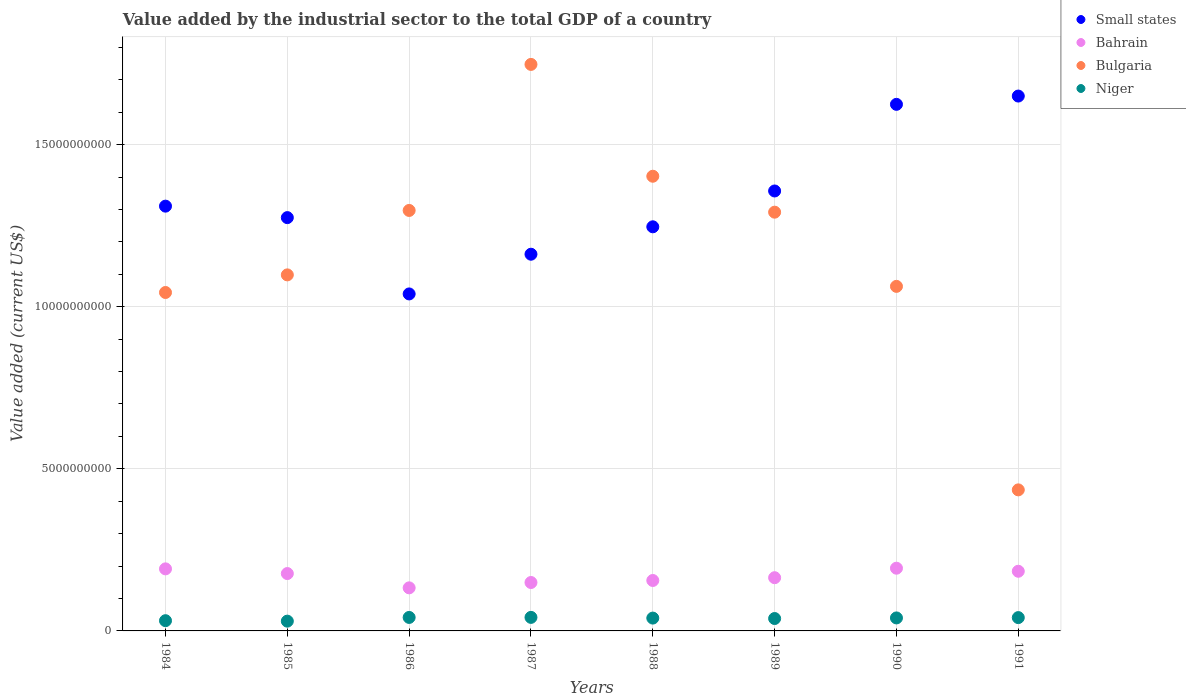How many different coloured dotlines are there?
Your answer should be very brief. 4. What is the value added by the industrial sector to the total GDP in Small states in 1987?
Your answer should be very brief. 1.16e+1. Across all years, what is the maximum value added by the industrial sector to the total GDP in Bahrain?
Give a very brief answer. 1.93e+09. Across all years, what is the minimum value added by the industrial sector to the total GDP in Small states?
Offer a terse response. 1.04e+1. What is the total value added by the industrial sector to the total GDP in Bulgaria in the graph?
Offer a terse response. 9.38e+1. What is the difference between the value added by the industrial sector to the total GDP in Niger in 1984 and that in 1989?
Your answer should be very brief. -6.68e+07. What is the difference between the value added by the industrial sector to the total GDP in Small states in 1988 and the value added by the industrial sector to the total GDP in Bahrain in 1989?
Keep it short and to the point. 1.08e+1. What is the average value added by the industrial sector to the total GDP in Small states per year?
Give a very brief answer. 1.33e+1. In the year 1985, what is the difference between the value added by the industrial sector to the total GDP in Bulgaria and value added by the industrial sector to the total GDP in Small states?
Offer a terse response. -1.77e+09. What is the ratio of the value added by the industrial sector to the total GDP in Niger in 1984 to that in 1988?
Your answer should be compact. 0.8. Is the difference between the value added by the industrial sector to the total GDP in Bulgaria in 1987 and 1988 greater than the difference between the value added by the industrial sector to the total GDP in Small states in 1987 and 1988?
Offer a terse response. Yes. What is the difference between the highest and the second highest value added by the industrial sector to the total GDP in Bahrain?
Keep it short and to the point. 2.04e+07. What is the difference between the highest and the lowest value added by the industrial sector to the total GDP in Niger?
Provide a short and direct response. 1.16e+08. How many dotlines are there?
Give a very brief answer. 4. How many legend labels are there?
Provide a short and direct response. 4. How are the legend labels stacked?
Your answer should be very brief. Vertical. What is the title of the graph?
Keep it short and to the point. Value added by the industrial sector to the total GDP of a country. What is the label or title of the Y-axis?
Keep it short and to the point. Value added (current US$). What is the Value added (current US$) of Small states in 1984?
Make the answer very short. 1.31e+1. What is the Value added (current US$) in Bahrain in 1984?
Ensure brevity in your answer.  1.91e+09. What is the Value added (current US$) in Bulgaria in 1984?
Offer a terse response. 1.04e+1. What is the Value added (current US$) of Niger in 1984?
Ensure brevity in your answer.  3.16e+08. What is the Value added (current US$) in Small states in 1985?
Your answer should be compact. 1.27e+1. What is the Value added (current US$) of Bahrain in 1985?
Ensure brevity in your answer.  1.77e+09. What is the Value added (current US$) in Bulgaria in 1985?
Your answer should be very brief. 1.10e+1. What is the Value added (current US$) in Niger in 1985?
Offer a very short reply. 3.01e+08. What is the Value added (current US$) in Small states in 1986?
Your answer should be very brief. 1.04e+1. What is the Value added (current US$) in Bahrain in 1986?
Give a very brief answer. 1.33e+09. What is the Value added (current US$) of Bulgaria in 1986?
Your response must be concise. 1.30e+1. What is the Value added (current US$) of Niger in 1986?
Offer a very short reply. 4.16e+08. What is the Value added (current US$) of Small states in 1987?
Keep it short and to the point. 1.16e+1. What is the Value added (current US$) in Bahrain in 1987?
Offer a very short reply. 1.49e+09. What is the Value added (current US$) in Bulgaria in 1987?
Your answer should be very brief. 1.75e+1. What is the Value added (current US$) in Niger in 1987?
Your answer should be very brief. 4.18e+08. What is the Value added (current US$) of Small states in 1988?
Your answer should be compact. 1.25e+1. What is the Value added (current US$) of Bahrain in 1988?
Give a very brief answer. 1.56e+09. What is the Value added (current US$) of Bulgaria in 1988?
Your answer should be very brief. 1.40e+1. What is the Value added (current US$) of Niger in 1988?
Offer a very short reply. 3.96e+08. What is the Value added (current US$) of Small states in 1989?
Make the answer very short. 1.36e+1. What is the Value added (current US$) in Bahrain in 1989?
Give a very brief answer. 1.64e+09. What is the Value added (current US$) in Bulgaria in 1989?
Your answer should be very brief. 1.29e+1. What is the Value added (current US$) of Niger in 1989?
Ensure brevity in your answer.  3.82e+08. What is the Value added (current US$) in Small states in 1990?
Keep it short and to the point. 1.62e+1. What is the Value added (current US$) in Bahrain in 1990?
Give a very brief answer. 1.93e+09. What is the Value added (current US$) in Bulgaria in 1990?
Your answer should be compact. 1.06e+1. What is the Value added (current US$) of Niger in 1990?
Ensure brevity in your answer.  4.01e+08. What is the Value added (current US$) of Small states in 1991?
Your answer should be very brief. 1.65e+1. What is the Value added (current US$) of Bahrain in 1991?
Give a very brief answer. 1.84e+09. What is the Value added (current US$) of Bulgaria in 1991?
Your answer should be very brief. 4.35e+09. What is the Value added (current US$) of Niger in 1991?
Your answer should be very brief. 4.11e+08. Across all years, what is the maximum Value added (current US$) of Small states?
Provide a succinct answer. 1.65e+1. Across all years, what is the maximum Value added (current US$) of Bahrain?
Provide a succinct answer. 1.93e+09. Across all years, what is the maximum Value added (current US$) of Bulgaria?
Provide a succinct answer. 1.75e+1. Across all years, what is the maximum Value added (current US$) of Niger?
Offer a very short reply. 4.18e+08. Across all years, what is the minimum Value added (current US$) in Small states?
Provide a succinct answer. 1.04e+1. Across all years, what is the minimum Value added (current US$) in Bahrain?
Offer a terse response. 1.33e+09. Across all years, what is the minimum Value added (current US$) in Bulgaria?
Your answer should be compact. 4.35e+09. Across all years, what is the minimum Value added (current US$) in Niger?
Provide a succinct answer. 3.01e+08. What is the total Value added (current US$) of Small states in the graph?
Keep it short and to the point. 1.07e+11. What is the total Value added (current US$) of Bahrain in the graph?
Provide a short and direct response. 1.35e+1. What is the total Value added (current US$) of Bulgaria in the graph?
Your response must be concise. 9.38e+1. What is the total Value added (current US$) of Niger in the graph?
Give a very brief answer. 3.04e+09. What is the difference between the Value added (current US$) in Small states in 1984 and that in 1985?
Keep it short and to the point. 3.54e+08. What is the difference between the Value added (current US$) of Bahrain in 1984 and that in 1985?
Your answer should be compact. 1.45e+08. What is the difference between the Value added (current US$) in Bulgaria in 1984 and that in 1985?
Provide a short and direct response. -5.43e+08. What is the difference between the Value added (current US$) in Niger in 1984 and that in 1985?
Keep it short and to the point. 1.42e+07. What is the difference between the Value added (current US$) in Small states in 1984 and that in 1986?
Your answer should be compact. 2.71e+09. What is the difference between the Value added (current US$) in Bahrain in 1984 and that in 1986?
Offer a very short reply. 5.86e+08. What is the difference between the Value added (current US$) in Bulgaria in 1984 and that in 1986?
Provide a succinct answer. -2.53e+09. What is the difference between the Value added (current US$) in Niger in 1984 and that in 1986?
Offer a very short reply. -1.00e+08. What is the difference between the Value added (current US$) in Small states in 1984 and that in 1987?
Provide a succinct answer. 1.48e+09. What is the difference between the Value added (current US$) in Bahrain in 1984 and that in 1987?
Your answer should be compact. 4.21e+08. What is the difference between the Value added (current US$) of Bulgaria in 1984 and that in 1987?
Provide a short and direct response. -7.04e+09. What is the difference between the Value added (current US$) in Niger in 1984 and that in 1987?
Your response must be concise. -1.02e+08. What is the difference between the Value added (current US$) of Small states in 1984 and that in 1988?
Offer a very short reply. 6.37e+08. What is the difference between the Value added (current US$) in Bahrain in 1984 and that in 1988?
Provide a short and direct response. 3.58e+08. What is the difference between the Value added (current US$) of Bulgaria in 1984 and that in 1988?
Provide a succinct answer. -3.59e+09. What is the difference between the Value added (current US$) in Niger in 1984 and that in 1988?
Provide a succinct answer. -8.02e+07. What is the difference between the Value added (current US$) in Small states in 1984 and that in 1989?
Give a very brief answer. -4.68e+08. What is the difference between the Value added (current US$) in Bahrain in 1984 and that in 1989?
Ensure brevity in your answer.  2.73e+08. What is the difference between the Value added (current US$) in Bulgaria in 1984 and that in 1989?
Your response must be concise. -2.48e+09. What is the difference between the Value added (current US$) in Niger in 1984 and that in 1989?
Your response must be concise. -6.68e+07. What is the difference between the Value added (current US$) of Small states in 1984 and that in 1990?
Your answer should be compact. -3.14e+09. What is the difference between the Value added (current US$) in Bahrain in 1984 and that in 1990?
Your response must be concise. -2.04e+07. What is the difference between the Value added (current US$) of Bulgaria in 1984 and that in 1990?
Provide a succinct answer. -1.89e+08. What is the difference between the Value added (current US$) of Niger in 1984 and that in 1990?
Provide a short and direct response. -8.51e+07. What is the difference between the Value added (current US$) in Small states in 1984 and that in 1991?
Provide a short and direct response. -3.40e+09. What is the difference between the Value added (current US$) of Bahrain in 1984 and that in 1991?
Your answer should be compact. 7.39e+07. What is the difference between the Value added (current US$) in Bulgaria in 1984 and that in 1991?
Provide a short and direct response. 6.09e+09. What is the difference between the Value added (current US$) in Niger in 1984 and that in 1991?
Your answer should be very brief. -9.52e+07. What is the difference between the Value added (current US$) in Small states in 1985 and that in 1986?
Ensure brevity in your answer.  2.35e+09. What is the difference between the Value added (current US$) in Bahrain in 1985 and that in 1986?
Give a very brief answer. 4.41e+08. What is the difference between the Value added (current US$) of Bulgaria in 1985 and that in 1986?
Keep it short and to the point. -1.99e+09. What is the difference between the Value added (current US$) of Niger in 1985 and that in 1986?
Provide a succinct answer. -1.14e+08. What is the difference between the Value added (current US$) of Small states in 1985 and that in 1987?
Offer a terse response. 1.13e+09. What is the difference between the Value added (current US$) in Bahrain in 1985 and that in 1987?
Offer a very short reply. 2.76e+08. What is the difference between the Value added (current US$) in Bulgaria in 1985 and that in 1987?
Offer a terse response. -6.49e+09. What is the difference between the Value added (current US$) of Niger in 1985 and that in 1987?
Give a very brief answer. -1.16e+08. What is the difference between the Value added (current US$) of Small states in 1985 and that in 1988?
Offer a terse response. 2.83e+08. What is the difference between the Value added (current US$) of Bahrain in 1985 and that in 1988?
Provide a short and direct response. 2.14e+08. What is the difference between the Value added (current US$) in Bulgaria in 1985 and that in 1988?
Provide a succinct answer. -3.04e+09. What is the difference between the Value added (current US$) in Niger in 1985 and that in 1988?
Provide a succinct answer. -9.45e+07. What is the difference between the Value added (current US$) in Small states in 1985 and that in 1989?
Give a very brief answer. -8.22e+08. What is the difference between the Value added (current US$) in Bahrain in 1985 and that in 1989?
Provide a short and direct response. 1.28e+08. What is the difference between the Value added (current US$) of Bulgaria in 1985 and that in 1989?
Provide a short and direct response. -1.93e+09. What is the difference between the Value added (current US$) of Niger in 1985 and that in 1989?
Ensure brevity in your answer.  -8.11e+07. What is the difference between the Value added (current US$) in Small states in 1985 and that in 1990?
Your answer should be very brief. -3.49e+09. What is the difference between the Value added (current US$) in Bahrain in 1985 and that in 1990?
Offer a terse response. -1.65e+08. What is the difference between the Value added (current US$) in Bulgaria in 1985 and that in 1990?
Your answer should be compact. 3.54e+08. What is the difference between the Value added (current US$) of Niger in 1985 and that in 1990?
Offer a terse response. -9.93e+07. What is the difference between the Value added (current US$) in Small states in 1985 and that in 1991?
Offer a very short reply. -3.75e+09. What is the difference between the Value added (current US$) in Bahrain in 1985 and that in 1991?
Make the answer very short. -7.08e+07. What is the difference between the Value added (current US$) of Bulgaria in 1985 and that in 1991?
Your answer should be very brief. 6.63e+09. What is the difference between the Value added (current US$) in Niger in 1985 and that in 1991?
Make the answer very short. -1.09e+08. What is the difference between the Value added (current US$) in Small states in 1986 and that in 1987?
Ensure brevity in your answer.  -1.22e+09. What is the difference between the Value added (current US$) of Bahrain in 1986 and that in 1987?
Your answer should be compact. -1.65e+08. What is the difference between the Value added (current US$) in Bulgaria in 1986 and that in 1987?
Offer a very short reply. -4.50e+09. What is the difference between the Value added (current US$) in Niger in 1986 and that in 1987?
Ensure brevity in your answer.  -1.77e+06. What is the difference between the Value added (current US$) of Small states in 1986 and that in 1988?
Offer a very short reply. -2.07e+09. What is the difference between the Value added (current US$) of Bahrain in 1986 and that in 1988?
Offer a very short reply. -2.27e+08. What is the difference between the Value added (current US$) of Bulgaria in 1986 and that in 1988?
Ensure brevity in your answer.  -1.06e+09. What is the difference between the Value added (current US$) in Niger in 1986 and that in 1988?
Provide a succinct answer. 2.00e+07. What is the difference between the Value added (current US$) in Small states in 1986 and that in 1989?
Provide a short and direct response. -3.18e+09. What is the difference between the Value added (current US$) of Bahrain in 1986 and that in 1989?
Your response must be concise. -3.13e+08. What is the difference between the Value added (current US$) of Bulgaria in 1986 and that in 1989?
Your answer should be very brief. 5.32e+07. What is the difference between the Value added (current US$) of Niger in 1986 and that in 1989?
Give a very brief answer. 3.34e+07. What is the difference between the Value added (current US$) of Small states in 1986 and that in 1990?
Provide a short and direct response. -5.85e+09. What is the difference between the Value added (current US$) in Bahrain in 1986 and that in 1990?
Your response must be concise. -6.06e+08. What is the difference between the Value added (current US$) of Bulgaria in 1986 and that in 1990?
Make the answer very short. 2.34e+09. What is the difference between the Value added (current US$) of Niger in 1986 and that in 1990?
Offer a very short reply. 1.51e+07. What is the difference between the Value added (current US$) in Small states in 1986 and that in 1991?
Offer a terse response. -6.10e+09. What is the difference between the Value added (current US$) of Bahrain in 1986 and that in 1991?
Offer a very short reply. -5.12e+08. What is the difference between the Value added (current US$) in Bulgaria in 1986 and that in 1991?
Offer a terse response. 8.62e+09. What is the difference between the Value added (current US$) of Niger in 1986 and that in 1991?
Offer a terse response. 4.98e+06. What is the difference between the Value added (current US$) in Small states in 1987 and that in 1988?
Offer a very short reply. -8.46e+08. What is the difference between the Value added (current US$) of Bahrain in 1987 and that in 1988?
Your answer should be compact. -6.23e+07. What is the difference between the Value added (current US$) in Bulgaria in 1987 and that in 1988?
Give a very brief answer. 3.45e+09. What is the difference between the Value added (current US$) of Niger in 1987 and that in 1988?
Your answer should be very brief. 2.17e+07. What is the difference between the Value added (current US$) in Small states in 1987 and that in 1989?
Provide a succinct answer. -1.95e+09. What is the difference between the Value added (current US$) in Bahrain in 1987 and that in 1989?
Provide a succinct answer. -1.48e+08. What is the difference between the Value added (current US$) in Bulgaria in 1987 and that in 1989?
Provide a short and direct response. 4.56e+09. What is the difference between the Value added (current US$) of Niger in 1987 and that in 1989?
Keep it short and to the point. 3.52e+07. What is the difference between the Value added (current US$) in Small states in 1987 and that in 1990?
Your answer should be compact. -4.62e+09. What is the difference between the Value added (current US$) of Bahrain in 1987 and that in 1990?
Your answer should be compact. -4.41e+08. What is the difference between the Value added (current US$) of Bulgaria in 1987 and that in 1990?
Make the answer very short. 6.85e+09. What is the difference between the Value added (current US$) of Niger in 1987 and that in 1990?
Your answer should be compact. 1.69e+07. What is the difference between the Value added (current US$) in Small states in 1987 and that in 1991?
Your response must be concise. -4.88e+09. What is the difference between the Value added (current US$) of Bahrain in 1987 and that in 1991?
Offer a very short reply. -3.47e+08. What is the difference between the Value added (current US$) in Bulgaria in 1987 and that in 1991?
Your answer should be very brief. 1.31e+1. What is the difference between the Value added (current US$) of Niger in 1987 and that in 1991?
Provide a short and direct response. 6.75e+06. What is the difference between the Value added (current US$) in Small states in 1988 and that in 1989?
Your response must be concise. -1.11e+09. What is the difference between the Value added (current US$) in Bahrain in 1988 and that in 1989?
Ensure brevity in your answer.  -8.59e+07. What is the difference between the Value added (current US$) of Bulgaria in 1988 and that in 1989?
Your answer should be compact. 1.11e+09. What is the difference between the Value added (current US$) of Niger in 1988 and that in 1989?
Your answer should be compact. 1.34e+07. What is the difference between the Value added (current US$) of Small states in 1988 and that in 1990?
Offer a terse response. -3.78e+09. What is the difference between the Value added (current US$) of Bahrain in 1988 and that in 1990?
Offer a very short reply. -3.79e+08. What is the difference between the Value added (current US$) in Bulgaria in 1988 and that in 1990?
Your answer should be very brief. 3.40e+09. What is the difference between the Value added (current US$) in Niger in 1988 and that in 1990?
Provide a short and direct response. -4.87e+06. What is the difference between the Value added (current US$) of Small states in 1988 and that in 1991?
Provide a succinct answer. -4.03e+09. What is the difference between the Value added (current US$) in Bahrain in 1988 and that in 1991?
Your answer should be compact. -2.85e+08. What is the difference between the Value added (current US$) of Bulgaria in 1988 and that in 1991?
Your answer should be compact. 9.67e+09. What is the difference between the Value added (current US$) in Niger in 1988 and that in 1991?
Your answer should be very brief. -1.50e+07. What is the difference between the Value added (current US$) of Small states in 1989 and that in 1990?
Keep it short and to the point. -2.67e+09. What is the difference between the Value added (current US$) in Bahrain in 1989 and that in 1990?
Your response must be concise. -2.93e+08. What is the difference between the Value added (current US$) in Bulgaria in 1989 and that in 1990?
Your answer should be very brief. 2.29e+09. What is the difference between the Value added (current US$) in Niger in 1989 and that in 1990?
Your answer should be compact. -1.83e+07. What is the difference between the Value added (current US$) in Small states in 1989 and that in 1991?
Your response must be concise. -2.93e+09. What is the difference between the Value added (current US$) in Bahrain in 1989 and that in 1991?
Offer a terse response. -1.99e+08. What is the difference between the Value added (current US$) in Bulgaria in 1989 and that in 1991?
Give a very brief answer. 8.57e+09. What is the difference between the Value added (current US$) in Niger in 1989 and that in 1991?
Your answer should be very brief. -2.84e+07. What is the difference between the Value added (current US$) in Small states in 1990 and that in 1991?
Provide a succinct answer. -2.56e+08. What is the difference between the Value added (current US$) in Bahrain in 1990 and that in 1991?
Provide a short and direct response. 9.42e+07. What is the difference between the Value added (current US$) of Bulgaria in 1990 and that in 1991?
Provide a short and direct response. 6.28e+09. What is the difference between the Value added (current US$) in Niger in 1990 and that in 1991?
Provide a short and direct response. -1.01e+07. What is the difference between the Value added (current US$) of Small states in 1984 and the Value added (current US$) of Bahrain in 1985?
Ensure brevity in your answer.  1.13e+1. What is the difference between the Value added (current US$) of Small states in 1984 and the Value added (current US$) of Bulgaria in 1985?
Your answer should be compact. 2.12e+09. What is the difference between the Value added (current US$) in Small states in 1984 and the Value added (current US$) in Niger in 1985?
Provide a succinct answer. 1.28e+1. What is the difference between the Value added (current US$) of Bahrain in 1984 and the Value added (current US$) of Bulgaria in 1985?
Your answer should be compact. -9.07e+09. What is the difference between the Value added (current US$) in Bahrain in 1984 and the Value added (current US$) in Niger in 1985?
Offer a very short reply. 1.61e+09. What is the difference between the Value added (current US$) in Bulgaria in 1984 and the Value added (current US$) in Niger in 1985?
Offer a very short reply. 1.01e+1. What is the difference between the Value added (current US$) of Small states in 1984 and the Value added (current US$) of Bahrain in 1986?
Offer a very short reply. 1.18e+1. What is the difference between the Value added (current US$) in Small states in 1984 and the Value added (current US$) in Bulgaria in 1986?
Your answer should be very brief. 1.33e+08. What is the difference between the Value added (current US$) in Small states in 1984 and the Value added (current US$) in Niger in 1986?
Provide a succinct answer. 1.27e+1. What is the difference between the Value added (current US$) in Bahrain in 1984 and the Value added (current US$) in Bulgaria in 1986?
Provide a short and direct response. -1.11e+1. What is the difference between the Value added (current US$) in Bahrain in 1984 and the Value added (current US$) in Niger in 1986?
Your answer should be very brief. 1.50e+09. What is the difference between the Value added (current US$) in Bulgaria in 1984 and the Value added (current US$) in Niger in 1986?
Ensure brevity in your answer.  1.00e+1. What is the difference between the Value added (current US$) in Small states in 1984 and the Value added (current US$) in Bahrain in 1987?
Your answer should be very brief. 1.16e+1. What is the difference between the Value added (current US$) in Small states in 1984 and the Value added (current US$) in Bulgaria in 1987?
Give a very brief answer. -4.37e+09. What is the difference between the Value added (current US$) of Small states in 1984 and the Value added (current US$) of Niger in 1987?
Your answer should be very brief. 1.27e+1. What is the difference between the Value added (current US$) of Bahrain in 1984 and the Value added (current US$) of Bulgaria in 1987?
Offer a very short reply. -1.56e+1. What is the difference between the Value added (current US$) of Bahrain in 1984 and the Value added (current US$) of Niger in 1987?
Give a very brief answer. 1.50e+09. What is the difference between the Value added (current US$) of Bulgaria in 1984 and the Value added (current US$) of Niger in 1987?
Offer a terse response. 1.00e+1. What is the difference between the Value added (current US$) of Small states in 1984 and the Value added (current US$) of Bahrain in 1988?
Ensure brevity in your answer.  1.15e+1. What is the difference between the Value added (current US$) in Small states in 1984 and the Value added (current US$) in Bulgaria in 1988?
Your response must be concise. -9.23e+08. What is the difference between the Value added (current US$) of Small states in 1984 and the Value added (current US$) of Niger in 1988?
Ensure brevity in your answer.  1.27e+1. What is the difference between the Value added (current US$) in Bahrain in 1984 and the Value added (current US$) in Bulgaria in 1988?
Make the answer very short. -1.21e+1. What is the difference between the Value added (current US$) in Bahrain in 1984 and the Value added (current US$) in Niger in 1988?
Offer a terse response. 1.52e+09. What is the difference between the Value added (current US$) of Bulgaria in 1984 and the Value added (current US$) of Niger in 1988?
Ensure brevity in your answer.  1.00e+1. What is the difference between the Value added (current US$) in Small states in 1984 and the Value added (current US$) in Bahrain in 1989?
Your answer should be compact. 1.15e+1. What is the difference between the Value added (current US$) of Small states in 1984 and the Value added (current US$) of Bulgaria in 1989?
Make the answer very short. 1.86e+08. What is the difference between the Value added (current US$) of Small states in 1984 and the Value added (current US$) of Niger in 1989?
Give a very brief answer. 1.27e+1. What is the difference between the Value added (current US$) in Bahrain in 1984 and the Value added (current US$) in Bulgaria in 1989?
Your answer should be compact. -1.10e+1. What is the difference between the Value added (current US$) in Bahrain in 1984 and the Value added (current US$) in Niger in 1989?
Give a very brief answer. 1.53e+09. What is the difference between the Value added (current US$) in Bulgaria in 1984 and the Value added (current US$) in Niger in 1989?
Your answer should be compact. 1.01e+1. What is the difference between the Value added (current US$) in Small states in 1984 and the Value added (current US$) in Bahrain in 1990?
Give a very brief answer. 1.12e+1. What is the difference between the Value added (current US$) in Small states in 1984 and the Value added (current US$) in Bulgaria in 1990?
Keep it short and to the point. 2.47e+09. What is the difference between the Value added (current US$) of Small states in 1984 and the Value added (current US$) of Niger in 1990?
Ensure brevity in your answer.  1.27e+1. What is the difference between the Value added (current US$) of Bahrain in 1984 and the Value added (current US$) of Bulgaria in 1990?
Provide a short and direct response. -8.71e+09. What is the difference between the Value added (current US$) of Bahrain in 1984 and the Value added (current US$) of Niger in 1990?
Offer a terse response. 1.51e+09. What is the difference between the Value added (current US$) of Bulgaria in 1984 and the Value added (current US$) of Niger in 1990?
Provide a short and direct response. 1.00e+1. What is the difference between the Value added (current US$) of Small states in 1984 and the Value added (current US$) of Bahrain in 1991?
Provide a short and direct response. 1.13e+1. What is the difference between the Value added (current US$) of Small states in 1984 and the Value added (current US$) of Bulgaria in 1991?
Your answer should be compact. 8.75e+09. What is the difference between the Value added (current US$) in Small states in 1984 and the Value added (current US$) in Niger in 1991?
Provide a short and direct response. 1.27e+1. What is the difference between the Value added (current US$) of Bahrain in 1984 and the Value added (current US$) of Bulgaria in 1991?
Give a very brief answer. -2.44e+09. What is the difference between the Value added (current US$) in Bahrain in 1984 and the Value added (current US$) in Niger in 1991?
Your answer should be compact. 1.50e+09. What is the difference between the Value added (current US$) of Bulgaria in 1984 and the Value added (current US$) of Niger in 1991?
Provide a succinct answer. 1.00e+1. What is the difference between the Value added (current US$) of Small states in 1985 and the Value added (current US$) of Bahrain in 1986?
Ensure brevity in your answer.  1.14e+1. What is the difference between the Value added (current US$) in Small states in 1985 and the Value added (current US$) in Bulgaria in 1986?
Keep it short and to the point. -2.21e+08. What is the difference between the Value added (current US$) in Small states in 1985 and the Value added (current US$) in Niger in 1986?
Your answer should be very brief. 1.23e+1. What is the difference between the Value added (current US$) in Bahrain in 1985 and the Value added (current US$) in Bulgaria in 1986?
Ensure brevity in your answer.  -1.12e+1. What is the difference between the Value added (current US$) of Bahrain in 1985 and the Value added (current US$) of Niger in 1986?
Your answer should be compact. 1.35e+09. What is the difference between the Value added (current US$) in Bulgaria in 1985 and the Value added (current US$) in Niger in 1986?
Make the answer very short. 1.06e+1. What is the difference between the Value added (current US$) in Small states in 1985 and the Value added (current US$) in Bahrain in 1987?
Provide a short and direct response. 1.13e+1. What is the difference between the Value added (current US$) in Small states in 1985 and the Value added (current US$) in Bulgaria in 1987?
Your answer should be very brief. -4.73e+09. What is the difference between the Value added (current US$) of Small states in 1985 and the Value added (current US$) of Niger in 1987?
Your answer should be compact. 1.23e+1. What is the difference between the Value added (current US$) in Bahrain in 1985 and the Value added (current US$) in Bulgaria in 1987?
Keep it short and to the point. -1.57e+1. What is the difference between the Value added (current US$) in Bahrain in 1985 and the Value added (current US$) in Niger in 1987?
Your answer should be compact. 1.35e+09. What is the difference between the Value added (current US$) of Bulgaria in 1985 and the Value added (current US$) of Niger in 1987?
Offer a terse response. 1.06e+1. What is the difference between the Value added (current US$) in Small states in 1985 and the Value added (current US$) in Bahrain in 1988?
Your answer should be compact. 1.12e+1. What is the difference between the Value added (current US$) of Small states in 1985 and the Value added (current US$) of Bulgaria in 1988?
Keep it short and to the point. -1.28e+09. What is the difference between the Value added (current US$) in Small states in 1985 and the Value added (current US$) in Niger in 1988?
Your answer should be very brief. 1.24e+1. What is the difference between the Value added (current US$) of Bahrain in 1985 and the Value added (current US$) of Bulgaria in 1988?
Your answer should be very brief. -1.23e+1. What is the difference between the Value added (current US$) in Bahrain in 1985 and the Value added (current US$) in Niger in 1988?
Offer a very short reply. 1.37e+09. What is the difference between the Value added (current US$) in Bulgaria in 1985 and the Value added (current US$) in Niger in 1988?
Your response must be concise. 1.06e+1. What is the difference between the Value added (current US$) of Small states in 1985 and the Value added (current US$) of Bahrain in 1989?
Provide a short and direct response. 1.11e+1. What is the difference between the Value added (current US$) of Small states in 1985 and the Value added (current US$) of Bulgaria in 1989?
Your response must be concise. -1.68e+08. What is the difference between the Value added (current US$) in Small states in 1985 and the Value added (current US$) in Niger in 1989?
Offer a very short reply. 1.24e+1. What is the difference between the Value added (current US$) of Bahrain in 1985 and the Value added (current US$) of Bulgaria in 1989?
Provide a succinct answer. -1.11e+1. What is the difference between the Value added (current US$) of Bahrain in 1985 and the Value added (current US$) of Niger in 1989?
Ensure brevity in your answer.  1.39e+09. What is the difference between the Value added (current US$) in Bulgaria in 1985 and the Value added (current US$) in Niger in 1989?
Keep it short and to the point. 1.06e+1. What is the difference between the Value added (current US$) in Small states in 1985 and the Value added (current US$) in Bahrain in 1990?
Keep it short and to the point. 1.08e+1. What is the difference between the Value added (current US$) in Small states in 1985 and the Value added (current US$) in Bulgaria in 1990?
Your answer should be very brief. 2.12e+09. What is the difference between the Value added (current US$) in Small states in 1985 and the Value added (current US$) in Niger in 1990?
Provide a succinct answer. 1.23e+1. What is the difference between the Value added (current US$) of Bahrain in 1985 and the Value added (current US$) of Bulgaria in 1990?
Ensure brevity in your answer.  -8.86e+09. What is the difference between the Value added (current US$) in Bahrain in 1985 and the Value added (current US$) in Niger in 1990?
Offer a terse response. 1.37e+09. What is the difference between the Value added (current US$) in Bulgaria in 1985 and the Value added (current US$) in Niger in 1990?
Offer a terse response. 1.06e+1. What is the difference between the Value added (current US$) of Small states in 1985 and the Value added (current US$) of Bahrain in 1991?
Provide a succinct answer. 1.09e+1. What is the difference between the Value added (current US$) of Small states in 1985 and the Value added (current US$) of Bulgaria in 1991?
Provide a short and direct response. 8.40e+09. What is the difference between the Value added (current US$) in Small states in 1985 and the Value added (current US$) in Niger in 1991?
Give a very brief answer. 1.23e+1. What is the difference between the Value added (current US$) of Bahrain in 1985 and the Value added (current US$) of Bulgaria in 1991?
Offer a very short reply. -2.58e+09. What is the difference between the Value added (current US$) of Bahrain in 1985 and the Value added (current US$) of Niger in 1991?
Provide a succinct answer. 1.36e+09. What is the difference between the Value added (current US$) of Bulgaria in 1985 and the Value added (current US$) of Niger in 1991?
Make the answer very short. 1.06e+1. What is the difference between the Value added (current US$) of Small states in 1986 and the Value added (current US$) of Bahrain in 1987?
Your answer should be very brief. 8.90e+09. What is the difference between the Value added (current US$) in Small states in 1986 and the Value added (current US$) in Bulgaria in 1987?
Your answer should be very brief. -7.08e+09. What is the difference between the Value added (current US$) in Small states in 1986 and the Value added (current US$) in Niger in 1987?
Your answer should be very brief. 9.98e+09. What is the difference between the Value added (current US$) in Bahrain in 1986 and the Value added (current US$) in Bulgaria in 1987?
Provide a succinct answer. -1.61e+1. What is the difference between the Value added (current US$) of Bahrain in 1986 and the Value added (current US$) of Niger in 1987?
Make the answer very short. 9.11e+08. What is the difference between the Value added (current US$) of Bulgaria in 1986 and the Value added (current US$) of Niger in 1987?
Keep it short and to the point. 1.26e+1. What is the difference between the Value added (current US$) in Small states in 1986 and the Value added (current US$) in Bahrain in 1988?
Keep it short and to the point. 8.84e+09. What is the difference between the Value added (current US$) of Small states in 1986 and the Value added (current US$) of Bulgaria in 1988?
Your response must be concise. -3.63e+09. What is the difference between the Value added (current US$) in Small states in 1986 and the Value added (current US$) in Niger in 1988?
Your response must be concise. 1.00e+1. What is the difference between the Value added (current US$) in Bahrain in 1986 and the Value added (current US$) in Bulgaria in 1988?
Make the answer very short. -1.27e+1. What is the difference between the Value added (current US$) of Bahrain in 1986 and the Value added (current US$) of Niger in 1988?
Make the answer very short. 9.33e+08. What is the difference between the Value added (current US$) of Bulgaria in 1986 and the Value added (current US$) of Niger in 1988?
Your response must be concise. 1.26e+1. What is the difference between the Value added (current US$) of Small states in 1986 and the Value added (current US$) of Bahrain in 1989?
Your answer should be very brief. 8.75e+09. What is the difference between the Value added (current US$) of Small states in 1986 and the Value added (current US$) of Bulgaria in 1989?
Provide a succinct answer. -2.52e+09. What is the difference between the Value added (current US$) in Small states in 1986 and the Value added (current US$) in Niger in 1989?
Keep it short and to the point. 1.00e+1. What is the difference between the Value added (current US$) of Bahrain in 1986 and the Value added (current US$) of Bulgaria in 1989?
Offer a very short reply. -1.16e+1. What is the difference between the Value added (current US$) in Bahrain in 1986 and the Value added (current US$) in Niger in 1989?
Provide a succinct answer. 9.46e+08. What is the difference between the Value added (current US$) of Bulgaria in 1986 and the Value added (current US$) of Niger in 1989?
Give a very brief answer. 1.26e+1. What is the difference between the Value added (current US$) of Small states in 1986 and the Value added (current US$) of Bahrain in 1990?
Offer a terse response. 8.46e+09. What is the difference between the Value added (current US$) in Small states in 1986 and the Value added (current US$) in Bulgaria in 1990?
Offer a very short reply. -2.33e+08. What is the difference between the Value added (current US$) in Small states in 1986 and the Value added (current US$) in Niger in 1990?
Your answer should be compact. 9.99e+09. What is the difference between the Value added (current US$) of Bahrain in 1986 and the Value added (current US$) of Bulgaria in 1990?
Make the answer very short. -9.30e+09. What is the difference between the Value added (current US$) of Bahrain in 1986 and the Value added (current US$) of Niger in 1990?
Keep it short and to the point. 9.28e+08. What is the difference between the Value added (current US$) of Bulgaria in 1986 and the Value added (current US$) of Niger in 1990?
Offer a very short reply. 1.26e+1. What is the difference between the Value added (current US$) in Small states in 1986 and the Value added (current US$) in Bahrain in 1991?
Your answer should be very brief. 8.55e+09. What is the difference between the Value added (current US$) of Small states in 1986 and the Value added (current US$) of Bulgaria in 1991?
Make the answer very short. 6.04e+09. What is the difference between the Value added (current US$) in Small states in 1986 and the Value added (current US$) in Niger in 1991?
Give a very brief answer. 9.98e+09. What is the difference between the Value added (current US$) of Bahrain in 1986 and the Value added (current US$) of Bulgaria in 1991?
Give a very brief answer. -3.02e+09. What is the difference between the Value added (current US$) of Bahrain in 1986 and the Value added (current US$) of Niger in 1991?
Make the answer very short. 9.18e+08. What is the difference between the Value added (current US$) of Bulgaria in 1986 and the Value added (current US$) of Niger in 1991?
Make the answer very short. 1.26e+1. What is the difference between the Value added (current US$) of Small states in 1987 and the Value added (current US$) of Bahrain in 1988?
Provide a succinct answer. 1.01e+1. What is the difference between the Value added (current US$) in Small states in 1987 and the Value added (current US$) in Bulgaria in 1988?
Make the answer very short. -2.41e+09. What is the difference between the Value added (current US$) in Small states in 1987 and the Value added (current US$) in Niger in 1988?
Your response must be concise. 1.12e+1. What is the difference between the Value added (current US$) of Bahrain in 1987 and the Value added (current US$) of Bulgaria in 1988?
Make the answer very short. -1.25e+1. What is the difference between the Value added (current US$) in Bahrain in 1987 and the Value added (current US$) in Niger in 1988?
Make the answer very short. 1.10e+09. What is the difference between the Value added (current US$) of Bulgaria in 1987 and the Value added (current US$) of Niger in 1988?
Keep it short and to the point. 1.71e+1. What is the difference between the Value added (current US$) of Small states in 1987 and the Value added (current US$) of Bahrain in 1989?
Your answer should be compact. 9.98e+09. What is the difference between the Value added (current US$) in Small states in 1987 and the Value added (current US$) in Bulgaria in 1989?
Give a very brief answer. -1.30e+09. What is the difference between the Value added (current US$) of Small states in 1987 and the Value added (current US$) of Niger in 1989?
Give a very brief answer. 1.12e+1. What is the difference between the Value added (current US$) of Bahrain in 1987 and the Value added (current US$) of Bulgaria in 1989?
Offer a very short reply. -1.14e+1. What is the difference between the Value added (current US$) in Bahrain in 1987 and the Value added (current US$) in Niger in 1989?
Your response must be concise. 1.11e+09. What is the difference between the Value added (current US$) of Bulgaria in 1987 and the Value added (current US$) of Niger in 1989?
Your answer should be very brief. 1.71e+1. What is the difference between the Value added (current US$) of Small states in 1987 and the Value added (current US$) of Bahrain in 1990?
Keep it short and to the point. 9.68e+09. What is the difference between the Value added (current US$) in Small states in 1987 and the Value added (current US$) in Bulgaria in 1990?
Your answer should be very brief. 9.92e+08. What is the difference between the Value added (current US$) in Small states in 1987 and the Value added (current US$) in Niger in 1990?
Give a very brief answer. 1.12e+1. What is the difference between the Value added (current US$) of Bahrain in 1987 and the Value added (current US$) of Bulgaria in 1990?
Provide a succinct answer. -9.13e+09. What is the difference between the Value added (current US$) in Bahrain in 1987 and the Value added (current US$) in Niger in 1990?
Provide a short and direct response. 1.09e+09. What is the difference between the Value added (current US$) of Bulgaria in 1987 and the Value added (current US$) of Niger in 1990?
Your answer should be very brief. 1.71e+1. What is the difference between the Value added (current US$) in Small states in 1987 and the Value added (current US$) in Bahrain in 1991?
Your answer should be very brief. 9.78e+09. What is the difference between the Value added (current US$) of Small states in 1987 and the Value added (current US$) of Bulgaria in 1991?
Keep it short and to the point. 7.27e+09. What is the difference between the Value added (current US$) in Small states in 1987 and the Value added (current US$) in Niger in 1991?
Provide a short and direct response. 1.12e+1. What is the difference between the Value added (current US$) of Bahrain in 1987 and the Value added (current US$) of Bulgaria in 1991?
Give a very brief answer. -2.86e+09. What is the difference between the Value added (current US$) of Bahrain in 1987 and the Value added (current US$) of Niger in 1991?
Your answer should be very brief. 1.08e+09. What is the difference between the Value added (current US$) in Bulgaria in 1987 and the Value added (current US$) in Niger in 1991?
Your answer should be compact. 1.71e+1. What is the difference between the Value added (current US$) in Small states in 1988 and the Value added (current US$) in Bahrain in 1989?
Offer a very short reply. 1.08e+1. What is the difference between the Value added (current US$) in Small states in 1988 and the Value added (current US$) in Bulgaria in 1989?
Provide a short and direct response. -4.51e+08. What is the difference between the Value added (current US$) in Small states in 1988 and the Value added (current US$) in Niger in 1989?
Provide a short and direct response. 1.21e+1. What is the difference between the Value added (current US$) of Bahrain in 1988 and the Value added (current US$) of Bulgaria in 1989?
Your answer should be compact. -1.14e+1. What is the difference between the Value added (current US$) of Bahrain in 1988 and the Value added (current US$) of Niger in 1989?
Ensure brevity in your answer.  1.17e+09. What is the difference between the Value added (current US$) in Bulgaria in 1988 and the Value added (current US$) in Niger in 1989?
Provide a short and direct response. 1.36e+1. What is the difference between the Value added (current US$) in Small states in 1988 and the Value added (current US$) in Bahrain in 1990?
Make the answer very short. 1.05e+1. What is the difference between the Value added (current US$) of Small states in 1988 and the Value added (current US$) of Bulgaria in 1990?
Your answer should be very brief. 1.84e+09. What is the difference between the Value added (current US$) of Small states in 1988 and the Value added (current US$) of Niger in 1990?
Your response must be concise. 1.21e+1. What is the difference between the Value added (current US$) of Bahrain in 1988 and the Value added (current US$) of Bulgaria in 1990?
Provide a short and direct response. -9.07e+09. What is the difference between the Value added (current US$) of Bahrain in 1988 and the Value added (current US$) of Niger in 1990?
Your answer should be compact. 1.15e+09. What is the difference between the Value added (current US$) of Bulgaria in 1988 and the Value added (current US$) of Niger in 1990?
Your response must be concise. 1.36e+1. What is the difference between the Value added (current US$) of Small states in 1988 and the Value added (current US$) of Bahrain in 1991?
Your answer should be compact. 1.06e+1. What is the difference between the Value added (current US$) in Small states in 1988 and the Value added (current US$) in Bulgaria in 1991?
Offer a terse response. 8.11e+09. What is the difference between the Value added (current US$) in Small states in 1988 and the Value added (current US$) in Niger in 1991?
Ensure brevity in your answer.  1.21e+1. What is the difference between the Value added (current US$) in Bahrain in 1988 and the Value added (current US$) in Bulgaria in 1991?
Give a very brief answer. -2.79e+09. What is the difference between the Value added (current US$) of Bahrain in 1988 and the Value added (current US$) of Niger in 1991?
Make the answer very short. 1.14e+09. What is the difference between the Value added (current US$) in Bulgaria in 1988 and the Value added (current US$) in Niger in 1991?
Your response must be concise. 1.36e+1. What is the difference between the Value added (current US$) of Small states in 1989 and the Value added (current US$) of Bahrain in 1990?
Your response must be concise. 1.16e+1. What is the difference between the Value added (current US$) of Small states in 1989 and the Value added (current US$) of Bulgaria in 1990?
Keep it short and to the point. 2.94e+09. What is the difference between the Value added (current US$) of Small states in 1989 and the Value added (current US$) of Niger in 1990?
Your response must be concise. 1.32e+1. What is the difference between the Value added (current US$) in Bahrain in 1989 and the Value added (current US$) in Bulgaria in 1990?
Keep it short and to the point. -8.99e+09. What is the difference between the Value added (current US$) of Bahrain in 1989 and the Value added (current US$) of Niger in 1990?
Your answer should be very brief. 1.24e+09. What is the difference between the Value added (current US$) in Bulgaria in 1989 and the Value added (current US$) in Niger in 1990?
Offer a very short reply. 1.25e+1. What is the difference between the Value added (current US$) in Small states in 1989 and the Value added (current US$) in Bahrain in 1991?
Keep it short and to the point. 1.17e+1. What is the difference between the Value added (current US$) in Small states in 1989 and the Value added (current US$) in Bulgaria in 1991?
Provide a succinct answer. 9.22e+09. What is the difference between the Value added (current US$) of Small states in 1989 and the Value added (current US$) of Niger in 1991?
Your response must be concise. 1.32e+1. What is the difference between the Value added (current US$) in Bahrain in 1989 and the Value added (current US$) in Bulgaria in 1991?
Your response must be concise. -2.71e+09. What is the difference between the Value added (current US$) in Bahrain in 1989 and the Value added (current US$) in Niger in 1991?
Your answer should be very brief. 1.23e+09. What is the difference between the Value added (current US$) in Bulgaria in 1989 and the Value added (current US$) in Niger in 1991?
Provide a succinct answer. 1.25e+1. What is the difference between the Value added (current US$) of Small states in 1990 and the Value added (current US$) of Bahrain in 1991?
Give a very brief answer. 1.44e+1. What is the difference between the Value added (current US$) of Small states in 1990 and the Value added (current US$) of Bulgaria in 1991?
Ensure brevity in your answer.  1.19e+1. What is the difference between the Value added (current US$) of Small states in 1990 and the Value added (current US$) of Niger in 1991?
Provide a succinct answer. 1.58e+1. What is the difference between the Value added (current US$) in Bahrain in 1990 and the Value added (current US$) in Bulgaria in 1991?
Offer a very short reply. -2.42e+09. What is the difference between the Value added (current US$) of Bahrain in 1990 and the Value added (current US$) of Niger in 1991?
Your answer should be very brief. 1.52e+09. What is the difference between the Value added (current US$) in Bulgaria in 1990 and the Value added (current US$) in Niger in 1991?
Make the answer very short. 1.02e+1. What is the average Value added (current US$) in Small states per year?
Provide a short and direct response. 1.33e+1. What is the average Value added (current US$) in Bahrain per year?
Provide a short and direct response. 1.68e+09. What is the average Value added (current US$) of Bulgaria per year?
Your answer should be compact. 1.17e+1. What is the average Value added (current US$) in Niger per year?
Your answer should be very brief. 3.80e+08. In the year 1984, what is the difference between the Value added (current US$) in Small states and Value added (current US$) in Bahrain?
Ensure brevity in your answer.  1.12e+1. In the year 1984, what is the difference between the Value added (current US$) of Small states and Value added (current US$) of Bulgaria?
Ensure brevity in your answer.  2.66e+09. In the year 1984, what is the difference between the Value added (current US$) of Small states and Value added (current US$) of Niger?
Provide a short and direct response. 1.28e+1. In the year 1984, what is the difference between the Value added (current US$) of Bahrain and Value added (current US$) of Bulgaria?
Provide a short and direct response. -8.52e+09. In the year 1984, what is the difference between the Value added (current US$) in Bahrain and Value added (current US$) in Niger?
Offer a terse response. 1.60e+09. In the year 1984, what is the difference between the Value added (current US$) of Bulgaria and Value added (current US$) of Niger?
Your answer should be very brief. 1.01e+1. In the year 1985, what is the difference between the Value added (current US$) of Small states and Value added (current US$) of Bahrain?
Your response must be concise. 1.10e+1. In the year 1985, what is the difference between the Value added (current US$) in Small states and Value added (current US$) in Bulgaria?
Offer a terse response. 1.77e+09. In the year 1985, what is the difference between the Value added (current US$) in Small states and Value added (current US$) in Niger?
Keep it short and to the point. 1.24e+1. In the year 1985, what is the difference between the Value added (current US$) in Bahrain and Value added (current US$) in Bulgaria?
Give a very brief answer. -9.21e+09. In the year 1985, what is the difference between the Value added (current US$) in Bahrain and Value added (current US$) in Niger?
Your answer should be compact. 1.47e+09. In the year 1985, what is the difference between the Value added (current US$) of Bulgaria and Value added (current US$) of Niger?
Your answer should be very brief. 1.07e+1. In the year 1986, what is the difference between the Value added (current US$) of Small states and Value added (current US$) of Bahrain?
Provide a succinct answer. 9.07e+09. In the year 1986, what is the difference between the Value added (current US$) in Small states and Value added (current US$) in Bulgaria?
Offer a very short reply. -2.57e+09. In the year 1986, what is the difference between the Value added (current US$) in Small states and Value added (current US$) in Niger?
Provide a short and direct response. 9.98e+09. In the year 1986, what is the difference between the Value added (current US$) in Bahrain and Value added (current US$) in Bulgaria?
Keep it short and to the point. -1.16e+1. In the year 1986, what is the difference between the Value added (current US$) in Bahrain and Value added (current US$) in Niger?
Provide a succinct answer. 9.13e+08. In the year 1986, what is the difference between the Value added (current US$) of Bulgaria and Value added (current US$) of Niger?
Your answer should be very brief. 1.26e+1. In the year 1987, what is the difference between the Value added (current US$) in Small states and Value added (current US$) in Bahrain?
Provide a short and direct response. 1.01e+1. In the year 1987, what is the difference between the Value added (current US$) in Small states and Value added (current US$) in Bulgaria?
Ensure brevity in your answer.  -5.85e+09. In the year 1987, what is the difference between the Value added (current US$) of Small states and Value added (current US$) of Niger?
Offer a very short reply. 1.12e+1. In the year 1987, what is the difference between the Value added (current US$) in Bahrain and Value added (current US$) in Bulgaria?
Make the answer very short. -1.60e+1. In the year 1987, what is the difference between the Value added (current US$) in Bahrain and Value added (current US$) in Niger?
Your answer should be compact. 1.08e+09. In the year 1987, what is the difference between the Value added (current US$) of Bulgaria and Value added (current US$) of Niger?
Provide a short and direct response. 1.71e+1. In the year 1988, what is the difference between the Value added (current US$) of Small states and Value added (current US$) of Bahrain?
Offer a very short reply. 1.09e+1. In the year 1988, what is the difference between the Value added (current US$) in Small states and Value added (current US$) in Bulgaria?
Offer a very short reply. -1.56e+09. In the year 1988, what is the difference between the Value added (current US$) in Small states and Value added (current US$) in Niger?
Ensure brevity in your answer.  1.21e+1. In the year 1988, what is the difference between the Value added (current US$) of Bahrain and Value added (current US$) of Bulgaria?
Offer a very short reply. -1.25e+1. In the year 1988, what is the difference between the Value added (current US$) in Bahrain and Value added (current US$) in Niger?
Offer a terse response. 1.16e+09. In the year 1988, what is the difference between the Value added (current US$) of Bulgaria and Value added (current US$) of Niger?
Provide a short and direct response. 1.36e+1. In the year 1989, what is the difference between the Value added (current US$) in Small states and Value added (current US$) in Bahrain?
Your response must be concise. 1.19e+1. In the year 1989, what is the difference between the Value added (current US$) in Small states and Value added (current US$) in Bulgaria?
Your response must be concise. 6.54e+08. In the year 1989, what is the difference between the Value added (current US$) in Small states and Value added (current US$) in Niger?
Provide a short and direct response. 1.32e+1. In the year 1989, what is the difference between the Value added (current US$) of Bahrain and Value added (current US$) of Bulgaria?
Provide a short and direct response. -1.13e+1. In the year 1989, what is the difference between the Value added (current US$) in Bahrain and Value added (current US$) in Niger?
Provide a short and direct response. 1.26e+09. In the year 1989, what is the difference between the Value added (current US$) of Bulgaria and Value added (current US$) of Niger?
Your answer should be compact. 1.25e+1. In the year 1990, what is the difference between the Value added (current US$) of Small states and Value added (current US$) of Bahrain?
Your answer should be compact. 1.43e+1. In the year 1990, what is the difference between the Value added (current US$) of Small states and Value added (current US$) of Bulgaria?
Ensure brevity in your answer.  5.61e+09. In the year 1990, what is the difference between the Value added (current US$) in Small states and Value added (current US$) in Niger?
Your answer should be compact. 1.58e+1. In the year 1990, what is the difference between the Value added (current US$) in Bahrain and Value added (current US$) in Bulgaria?
Offer a terse response. -8.69e+09. In the year 1990, what is the difference between the Value added (current US$) in Bahrain and Value added (current US$) in Niger?
Offer a very short reply. 1.53e+09. In the year 1990, what is the difference between the Value added (current US$) in Bulgaria and Value added (current US$) in Niger?
Your answer should be compact. 1.02e+1. In the year 1991, what is the difference between the Value added (current US$) in Small states and Value added (current US$) in Bahrain?
Provide a short and direct response. 1.47e+1. In the year 1991, what is the difference between the Value added (current US$) in Small states and Value added (current US$) in Bulgaria?
Your answer should be compact. 1.21e+1. In the year 1991, what is the difference between the Value added (current US$) of Small states and Value added (current US$) of Niger?
Your answer should be compact. 1.61e+1. In the year 1991, what is the difference between the Value added (current US$) in Bahrain and Value added (current US$) in Bulgaria?
Make the answer very short. -2.51e+09. In the year 1991, what is the difference between the Value added (current US$) in Bahrain and Value added (current US$) in Niger?
Provide a succinct answer. 1.43e+09. In the year 1991, what is the difference between the Value added (current US$) in Bulgaria and Value added (current US$) in Niger?
Offer a terse response. 3.94e+09. What is the ratio of the Value added (current US$) in Small states in 1984 to that in 1985?
Your answer should be very brief. 1.03. What is the ratio of the Value added (current US$) in Bahrain in 1984 to that in 1985?
Ensure brevity in your answer.  1.08. What is the ratio of the Value added (current US$) of Bulgaria in 1984 to that in 1985?
Offer a terse response. 0.95. What is the ratio of the Value added (current US$) of Niger in 1984 to that in 1985?
Your response must be concise. 1.05. What is the ratio of the Value added (current US$) in Small states in 1984 to that in 1986?
Ensure brevity in your answer.  1.26. What is the ratio of the Value added (current US$) in Bahrain in 1984 to that in 1986?
Provide a short and direct response. 1.44. What is the ratio of the Value added (current US$) of Bulgaria in 1984 to that in 1986?
Your answer should be compact. 0.8. What is the ratio of the Value added (current US$) in Niger in 1984 to that in 1986?
Give a very brief answer. 0.76. What is the ratio of the Value added (current US$) in Small states in 1984 to that in 1987?
Give a very brief answer. 1.13. What is the ratio of the Value added (current US$) in Bahrain in 1984 to that in 1987?
Keep it short and to the point. 1.28. What is the ratio of the Value added (current US$) of Bulgaria in 1984 to that in 1987?
Offer a very short reply. 0.6. What is the ratio of the Value added (current US$) in Niger in 1984 to that in 1987?
Your answer should be very brief. 0.76. What is the ratio of the Value added (current US$) in Small states in 1984 to that in 1988?
Offer a very short reply. 1.05. What is the ratio of the Value added (current US$) in Bahrain in 1984 to that in 1988?
Provide a succinct answer. 1.23. What is the ratio of the Value added (current US$) of Bulgaria in 1984 to that in 1988?
Your answer should be very brief. 0.74. What is the ratio of the Value added (current US$) of Niger in 1984 to that in 1988?
Offer a very short reply. 0.8. What is the ratio of the Value added (current US$) of Small states in 1984 to that in 1989?
Offer a terse response. 0.97. What is the ratio of the Value added (current US$) in Bahrain in 1984 to that in 1989?
Provide a short and direct response. 1.17. What is the ratio of the Value added (current US$) of Bulgaria in 1984 to that in 1989?
Provide a short and direct response. 0.81. What is the ratio of the Value added (current US$) of Niger in 1984 to that in 1989?
Keep it short and to the point. 0.83. What is the ratio of the Value added (current US$) of Small states in 1984 to that in 1990?
Ensure brevity in your answer.  0.81. What is the ratio of the Value added (current US$) in Bahrain in 1984 to that in 1990?
Your response must be concise. 0.99. What is the ratio of the Value added (current US$) in Bulgaria in 1984 to that in 1990?
Keep it short and to the point. 0.98. What is the ratio of the Value added (current US$) in Niger in 1984 to that in 1990?
Give a very brief answer. 0.79. What is the ratio of the Value added (current US$) of Small states in 1984 to that in 1991?
Make the answer very short. 0.79. What is the ratio of the Value added (current US$) of Bahrain in 1984 to that in 1991?
Ensure brevity in your answer.  1.04. What is the ratio of the Value added (current US$) of Bulgaria in 1984 to that in 1991?
Provide a short and direct response. 2.4. What is the ratio of the Value added (current US$) of Niger in 1984 to that in 1991?
Keep it short and to the point. 0.77. What is the ratio of the Value added (current US$) of Small states in 1985 to that in 1986?
Your response must be concise. 1.23. What is the ratio of the Value added (current US$) of Bahrain in 1985 to that in 1986?
Make the answer very short. 1.33. What is the ratio of the Value added (current US$) of Bulgaria in 1985 to that in 1986?
Offer a very short reply. 0.85. What is the ratio of the Value added (current US$) in Niger in 1985 to that in 1986?
Your answer should be very brief. 0.72. What is the ratio of the Value added (current US$) in Small states in 1985 to that in 1987?
Your answer should be very brief. 1.1. What is the ratio of the Value added (current US$) of Bahrain in 1985 to that in 1987?
Your answer should be very brief. 1.18. What is the ratio of the Value added (current US$) in Bulgaria in 1985 to that in 1987?
Ensure brevity in your answer.  0.63. What is the ratio of the Value added (current US$) of Niger in 1985 to that in 1987?
Your answer should be very brief. 0.72. What is the ratio of the Value added (current US$) in Small states in 1985 to that in 1988?
Offer a very short reply. 1.02. What is the ratio of the Value added (current US$) in Bahrain in 1985 to that in 1988?
Ensure brevity in your answer.  1.14. What is the ratio of the Value added (current US$) in Bulgaria in 1985 to that in 1988?
Make the answer very short. 0.78. What is the ratio of the Value added (current US$) of Niger in 1985 to that in 1988?
Make the answer very short. 0.76. What is the ratio of the Value added (current US$) in Small states in 1985 to that in 1989?
Provide a succinct answer. 0.94. What is the ratio of the Value added (current US$) of Bahrain in 1985 to that in 1989?
Offer a very short reply. 1.08. What is the ratio of the Value added (current US$) in Bulgaria in 1985 to that in 1989?
Give a very brief answer. 0.85. What is the ratio of the Value added (current US$) in Niger in 1985 to that in 1989?
Your response must be concise. 0.79. What is the ratio of the Value added (current US$) in Small states in 1985 to that in 1990?
Give a very brief answer. 0.78. What is the ratio of the Value added (current US$) of Bahrain in 1985 to that in 1990?
Your answer should be compact. 0.91. What is the ratio of the Value added (current US$) of Bulgaria in 1985 to that in 1990?
Give a very brief answer. 1.03. What is the ratio of the Value added (current US$) of Niger in 1985 to that in 1990?
Give a very brief answer. 0.75. What is the ratio of the Value added (current US$) in Small states in 1985 to that in 1991?
Your response must be concise. 0.77. What is the ratio of the Value added (current US$) of Bahrain in 1985 to that in 1991?
Make the answer very short. 0.96. What is the ratio of the Value added (current US$) of Bulgaria in 1985 to that in 1991?
Provide a succinct answer. 2.52. What is the ratio of the Value added (current US$) of Niger in 1985 to that in 1991?
Offer a terse response. 0.73. What is the ratio of the Value added (current US$) of Small states in 1986 to that in 1987?
Your response must be concise. 0.89. What is the ratio of the Value added (current US$) of Bahrain in 1986 to that in 1987?
Offer a terse response. 0.89. What is the ratio of the Value added (current US$) in Bulgaria in 1986 to that in 1987?
Your answer should be compact. 0.74. What is the ratio of the Value added (current US$) of Niger in 1986 to that in 1987?
Give a very brief answer. 1. What is the ratio of the Value added (current US$) of Small states in 1986 to that in 1988?
Your answer should be compact. 0.83. What is the ratio of the Value added (current US$) of Bahrain in 1986 to that in 1988?
Offer a very short reply. 0.85. What is the ratio of the Value added (current US$) in Bulgaria in 1986 to that in 1988?
Provide a succinct answer. 0.92. What is the ratio of the Value added (current US$) in Niger in 1986 to that in 1988?
Make the answer very short. 1.05. What is the ratio of the Value added (current US$) in Small states in 1986 to that in 1989?
Ensure brevity in your answer.  0.77. What is the ratio of the Value added (current US$) in Bahrain in 1986 to that in 1989?
Ensure brevity in your answer.  0.81. What is the ratio of the Value added (current US$) in Bulgaria in 1986 to that in 1989?
Give a very brief answer. 1. What is the ratio of the Value added (current US$) of Niger in 1986 to that in 1989?
Give a very brief answer. 1.09. What is the ratio of the Value added (current US$) in Small states in 1986 to that in 1990?
Offer a very short reply. 0.64. What is the ratio of the Value added (current US$) of Bahrain in 1986 to that in 1990?
Offer a terse response. 0.69. What is the ratio of the Value added (current US$) in Bulgaria in 1986 to that in 1990?
Provide a succinct answer. 1.22. What is the ratio of the Value added (current US$) of Niger in 1986 to that in 1990?
Your answer should be compact. 1.04. What is the ratio of the Value added (current US$) of Small states in 1986 to that in 1991?
Make the answer very short. 0.63. What is the ratio of the Value added (current US$) in Bahrain in 1986 to that in 1991?
Ensure brevity in your answer.  0.72. What is the ratio of the Value added (current US$) of Bulgaria in 1986 to that in 1991?
Offer a very short reply. 2.98. What is the ratio of the Value added (current US$) in Niger in 1986 to that in 1991?
Provide a short and direct response. 1.01. What is the ratio of the Value added (current US$) of Small states in 1987 to that in 1988?
Your answer should be compact. 0.93. What is the ratio of the Value added (current US$) of Bahrain in 1987 to that in 1988?
Your answer should be compact. 0.96. What is the ratio of the Value added (current US$) in Bulgaria in 1987 to that in 1988?
Provide a succinct answer. 1.25. What is the ratio of the Value added (current US$) of Niger in 1987 to that in 1988?
Ensure brevity in your answer.  1.05. What is the ratio of the Value added (current US$) in Small states in 1987 to that in 1989?
Provide a succinct answer. 0.86. What is the ratio of the Value added (current US$) of Bahrain in 1987 to that in 1989?
Your answer should be very brief. 0.91. What is the ratio of the Value added (current US$) in Bulgaria in 1987 to that in 1989?
Provide a short and direct response. 1.35. What is the ratio of the Value added (current US$) of Niger in 1987 to that in 1989?
Your answer should be compact. 1.09. What is the ratio of the Value added (current US$) in Small states in 1987 to that in 1990?
Your answer should be very brief. 0.72. What is the ratio of the Value added (current US$) of Bahrain in 1987 to that in 1990?
Offer a terse response. 0.77. What is the ratio of the Value added (current US$) of Bulgaria in 1987 to that in 1990?
Your response must be concise. 1.64. What is the ratio of the Value added (current US$) of Niger in 1987 to that in 1990?
Make the answer very short. 1.04. What is the ratio of the Value added (current US$) of Small states in 1987 to that in 1991?
Your answer should be very brief. 0.7. What is the ratio of the Value added (current US$) in Bahrain in 1987 to that in 1991?
Keep it short and to the point. 0.81. What is the ratio of the Value added (current US$) in Bulgaria in 1987 to that in 1991?
Your response must be concise. 4.02. What is the ratio of the Value added (current US$) of Niger in 1987 to that in 1991?
Make the answer very short. 1.02. What is the ratio of the Value added (current US$) of Small states in 1988 to that in 1989?
Offer a terse response. 0.92. What is the ratio of the Value added (current US$) in Bahrain in 1988 to that in 1989?
Give a very brief answer. 0.95. What is the ratio of the Value added (current US$) of Bulgaria in 1988 to that in 1989?
Your answer should be very brief. 1.09. What is the ratio of the Value added (current US$) in Niger in 1988 to that in 1989?
Offer a terse response. 1.03. What is the ratio of the Value added (current US$) of Small states in 1988 to that in 1990?
Give a very brief answer. 0.77. What is the ratio of the Value added (current US$) of Bahrain in 1988 to that in 1990?
Ensure brevity in your answer.  0.8. What is the ratio of the Value added (current US$) of Bulgaria in 1988 to that in 1990?
Make the answer very short. 1.32. What is the ratio of the Value added (current US$) of Niger in 1988 to that in 1990?
Make the answer very short. 0.99. What is the ratio of the Value added (current US$) in Small states in 1988 to that in 1991?
Provide a short and direct response. 0.76. What is the ratio of the Value added (current US$) of Bahrain in 1988 to that in 1991?
Give a very brief answer. 0.85. What is the ratio of the Value added (current US$) in Bulgaria in 1988 to that in 1991?
Offer a very short reply. 3.22. What is the ratio of the Value added (current US$) of Niger in 1988 to that in 1991?
Keep it short and to the point. 0.96. What is the ratio of the Value added (current US$) in Small states in 1989 to that in 1990?
Make the answer very short. 0.84. What is the ratio of the Value added (current US$) of Bahrain in 1989 to that in 1990?
Keep it short and to the point. 0.85. What is the ratio of the Value added (current US$) of Bulgaria in 1989 to that in 1990?
Provide a short and direct response. 1.22. What is the ratio of the Value added (current US$) of Niger in 1989 to that in 1990?
Keep it short and to the point. 0.95. What is the ratio of the Value added (current US$) of Small states in 1989 to that in 1991?
Your answer should be very brief. 0.82. What is the ratio of the Value added (current US$) in Bahrain in 1989 to that in 1991?
Give a very brief answer. 0.89. What is the ratio of the Value added (current US$) of Bulgaria in 1989 to that in 1991?
Offer a terse response. 2.97. What is the ratio of the Value added (current US$) in Niger in 1989 to that in 1991?
Your answer should be very brief. 0.93. What is the ratio of the Value added (current US$) in Small states in 1990 to that in 1991?
Your answer should be very brief. 0.98. What is the ratio of the Value added (current US$) in Bahrain in 1990 to that in 1991?
Keep it short and to the point. 1.05. What is the ratio of the Value added (current US$) of Bulgaria in 1990 to that in 1991?
Give a very brief answer. 2.44. What is the ratio of the Value added (current US$) of Niger in 1990 to that in 1991?
Offer a terse response. 0.98. What is the difference between the highest and the second highest Value added (current US$) in Small states?
Ensure brevity in your answer.  2.56e+08. What is the difference between the highest and the second highest Value added (current US$) of Bahrain?
Give a very brief answer. 2.04e+07. What is the difference between the highest and the second highest Value added (current US$) in Bulgaria?
Provide a short and direct response. 3.45e+09. What is the difference between the highest and the second highest Value added (current US$) in Niger?
Provide a short and direct response. 1.77e+06. What is the difference between the highest and the lowest Value added (current US$) in Small states?
Ensure brevity in your answer.  6.10e+09. What is the difference between the highest and the lowest Value added (current US$) in Bahrain?
Offer a very short reply. 6.06e+08. What is the difference between the highest and the lowest Value added (current US$) of Bulgaria?
Provide a short and direct response. 1.31e+1. What is the difference between the highest and the lowest Value added (current US$) of Niger?
Provide a succinct answer. 1.16e+08. 